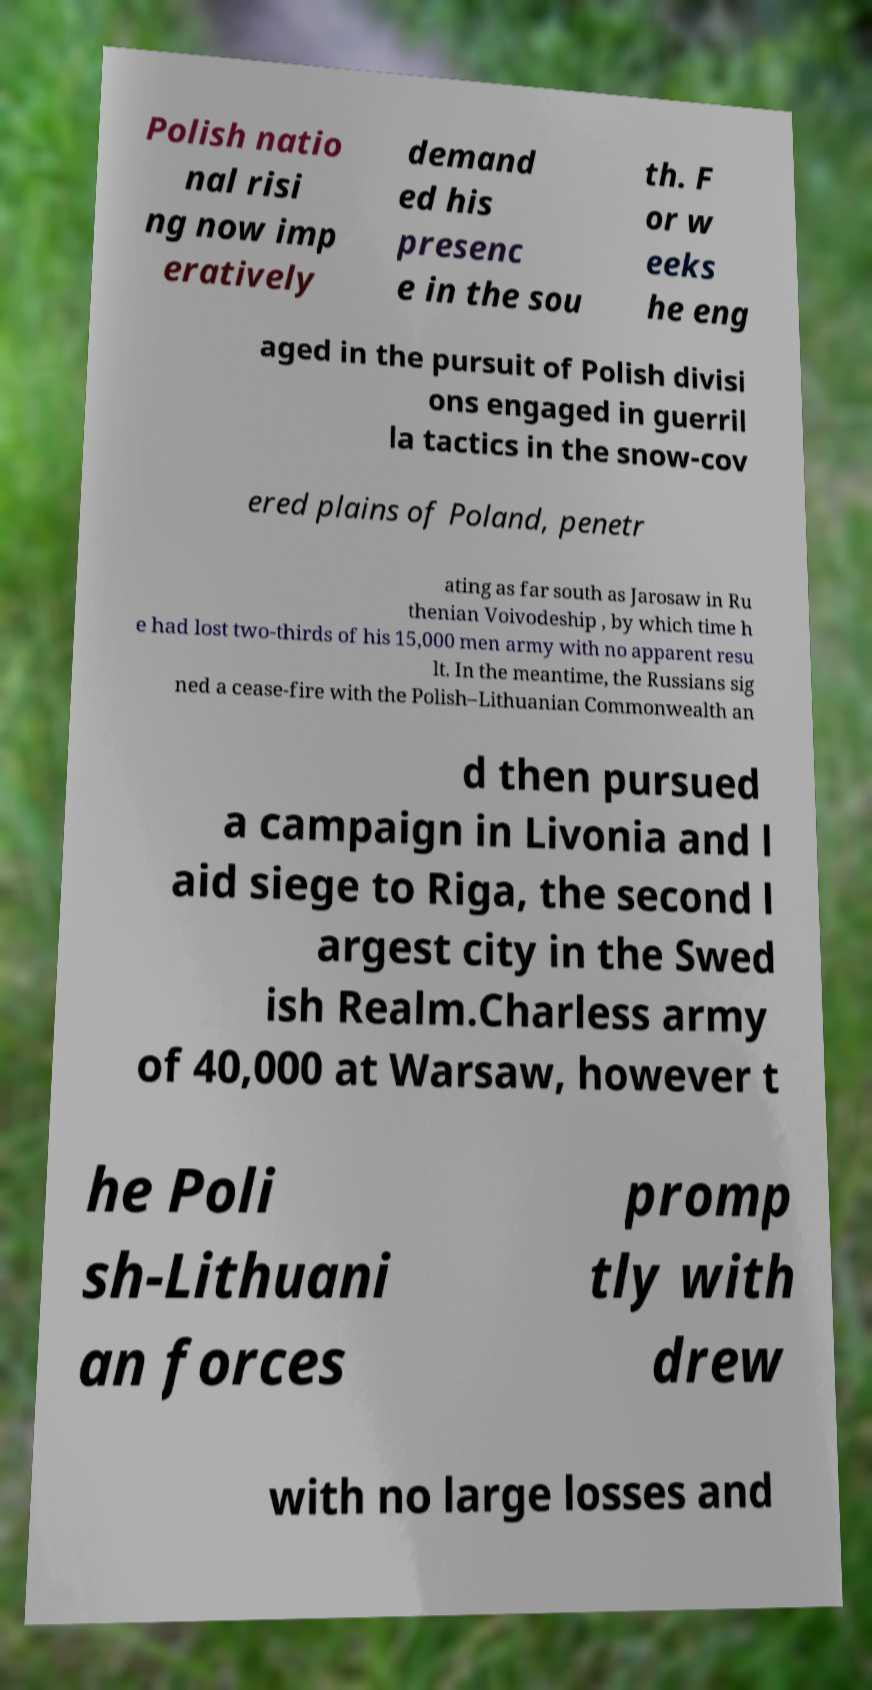Could you assist in decoding the text presented in this image and type it out clearly? Polish natio nal risi ng now imp eratively demand ed his presenc e in the sou th. F or w eeks he eng aged in the pursuit of Polish divisi ons engaged in guerril la tactics in the snow-cov ered plains of Poland, penetr ating as far south as Jarosaw in Ru thenian Voivodeship , by which time h e had lost two-thirds of his 15,000 men army with no apparent resu lt. In the meantime, the Russians sig ned a cease-fire with the Polish–Lithuanian Commonwealth an d then pursued a campaign in Livonia and l aid siege to Riga, the second l argest city in the Swed ish Realm.Charless army of 40,000 at Warsaw, however t he Poli sh-Lithuani an forces promp tly with drew with no large losses and 